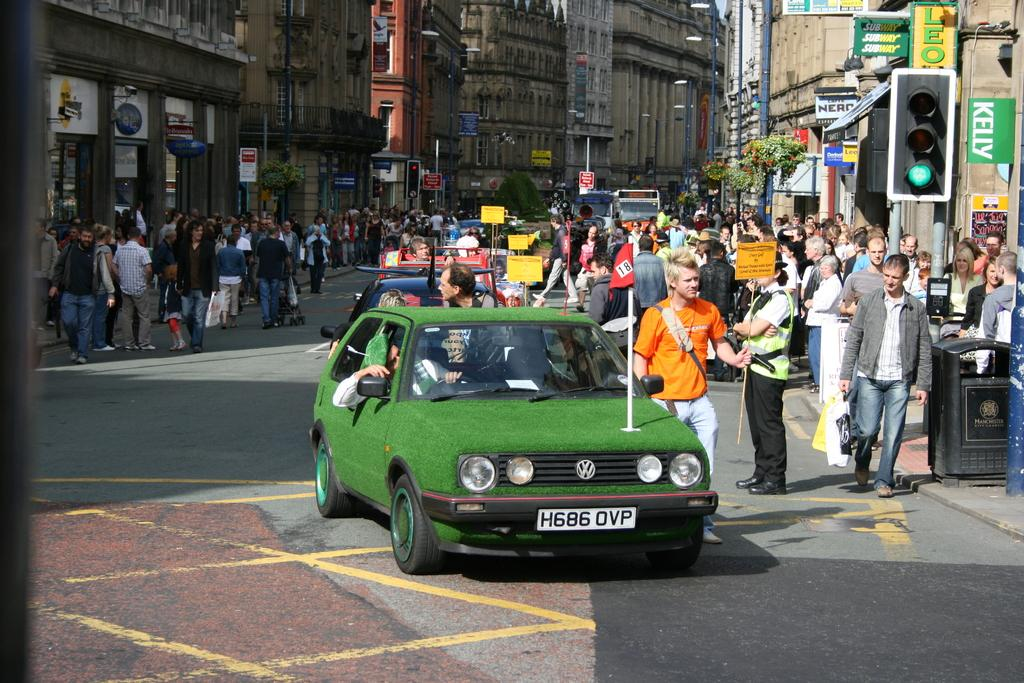<image>
Describe the image concisely. A car that has been made to look like a putting green and has the licence plate h686ovp on it. 